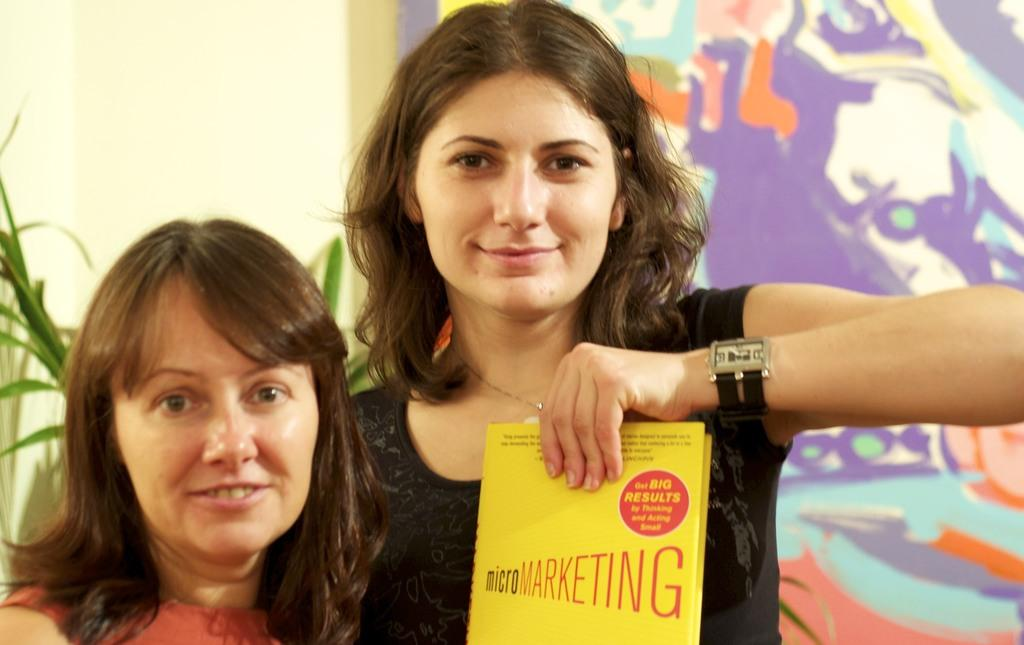<image>
Give a short and clear explanation of the subsequent image. Woman holding a yellow book which says microMarketing. 